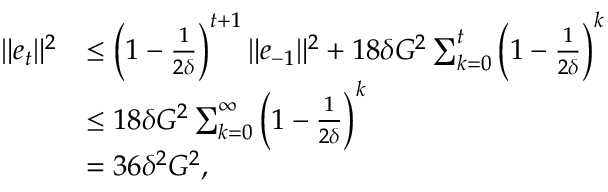<formula> <loc_0><loc_0><loc_500><loc_500>\begin{array} { r l } { \| e _ { t } \| ^ { 2 } } & { \leq \left ( 1 - \frac { 1 } { 2 \delta } \right ) ^ { t + 1 } \| e _ { - 1 } \| ^ { 2 } + 1 8 \delta G ^ { 2 } \sum _ { k = 0 } ^ { t } \left ( 1 - \frac { 1 } { 2 \delta } \right ) ^ { k } } \\ & { \leq 1 8 \delta G ^ { 2 } \sum _ { k = 0 } ^ { \infty } \left ( 1 - \frac { 1 } { 2 \delta } \right ) ^ { k } } \\ & { = 3 6 \delta ^ { 2 } G ^ { 2 } , } \end{array}</formula> 